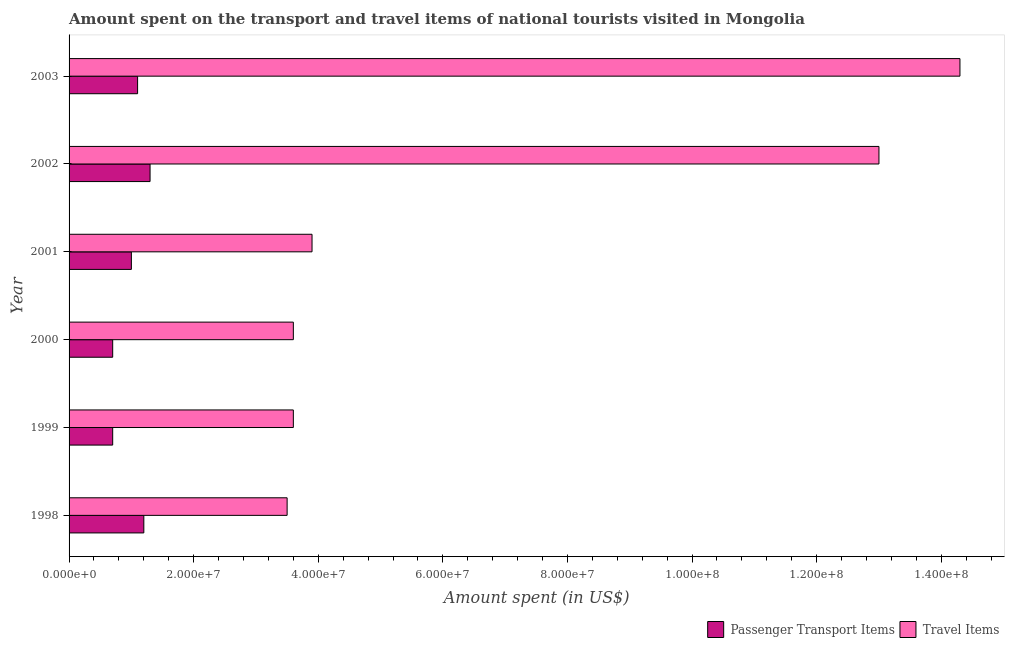How many groups of bars are there?
Keep it short and to the point. 6. Are the number of bars per tick equal to the number of legend labels?
Your answer should be very brief. Yes. How many bars are there on the 6th tick from the bottom?
Offer a terse response. 2. What is the label of the 3rd group of bars from the top?
Keep it short and to the point. 2001. In how many cases, is the number of bars for a given year not equal to the number of legend labels?
Ensure brevity in your answer.  0. What is the amount spent on passenger transport items in 1999?
Give a very brief answer. 7.00e+06. Across all years, what is the maximum amount spent on passenger transport items?
Provide a succinct answer. 1.30e+07. Across all years, what is the minimum amount spent in travel items?
Offer a very short reply. 3.50e+07. In which year was the amount spent on passenger transport items maximum?
Provide a succinct answer. 2002. In which year was the amount spent in travel items minimum?
Your response must be concise. 1998. What is the total amount spent in travel items in the graph?
Make the answer very short. 4.19e+08. What is the difference between the amount spent on passenger transport items in 1999 and that in 2001?
Your answer should be very brief. -3.00e+06. What is the difference between the amount spent in travel items in 1998 and the amount spent on passenger transport items in 2002?
Your response must be concise. 2.20e+07. What is the average amount spent on passenger transport items per year?
Keep it short and to the point. 1.00e+07. In the year 1999, what is the difference between the amount spent in travel items and amount spent on passenger transport items?
Your answer should be compact. 2.90e+07. What is the ratio of the amount spent in travel items in 2001 to that in 2003?
Keep it short and to the point. 0.27. Is the difference between the amount spent on passenger transport items in 2000 and 2001 greater than the difference between the amount spent in travel items in 2000 and 2001?
Offer a terse response. No. What is the difference between the highest and the second highest amount spent in travel items?
Make the answer very short. 1.30e+07. What is the difference between the highest and the lowest amount spent on passenger transport items?
Provide a succinct answer. 6.00e+06. What does the 1st bar from the top in 1999 represents?
Keep it short and to the point. Travel Items. What does the 2nd bar from the bottom in 2001 represents?
Provide a succinct answer. Travel Items. How many bars are there?
Offer a terse response. 12. What is the difference between two consecutive major ticks on the X-axis?
Provide a succinct answer. 2.00e+07. Are the values on the major ticks of X-axis written in scientific E-notation?
Offer a terse response. Yes. Does the graph contain grids?
Make the answer very short. No. Where does the legend appear in the graph?
Give a very brief answer. Bottom right. How are the legend labels stacked?
Provide a succinct answer. Horizontal. What is the title of the graph?
Your answer should be compact. Amount spent on the transport and travel items of national tourists visited in Mongolia. What is the label or title of the X-axis?
Offer a terse response. Amount spent (in US$). What is the Amount spent (in US$) of Passenger Transport Items in 1998?
Offer a very short reply. 1.20e+07. What is the Amount spent (in US$) of Travel Items in 1998?
Give a very brief answer. 3.50e+07. What is the Amount spent (in US$) in Travel Items in 1999?
Give a very brief answer. 3.60e+07. What is the Amount spent (in US$) in Passenger Transport Items in 2000?
Ensure brevity in your answer.  7.00e+06. What is the Amount spent (in US$) in Travel Items in 2000?
Provide a succinct answer. 3.60e+07. What is the Amount spent (in US$) in Travel Items in 2001?
Your answer should be very brief. 3.90e+07. What is the Amount spent (in US$) of Passenger Transport Items in 2002?
Offer a very short reply. 1.30e+07. What is the Amount spent (in US$) of Travel Items in 2002?
Ensure brevity in your answer.  1.30e+08. What is the Amount spent (in US$) of Passenger Transport Items in 2003?
Provide a short and direct response. 1.10e+07. What is the Amount spent (in US$) in Travel Items in 2003?
Your response must be concise. 1.43e+08. Across all years, what is the maximum Amount spent (in US$) of Passenger Transport Items?
Offer a very short reply. 1.30e+07. Across all years, what is the maximum Amount spent (in US$) in Travel Items?
Your response must be concise. 1.43e+08. Across all years, what is the minimum Amount spent (in US$) in Passenger Transport Items?
Ensure brevity in your answer.  7.00e+06. Across all years, what is the minimum Amount spent (in US$) of Travel Items?
Ensure brevity in your answer.  3.50e+07. What is the total Amount spent (in US$) in Passenger Transport Items in the graph?
Provide a succinct answer. 6.00e+07. What is the total Amount spent (in US$) of Travel Items in the graph?
Offer a terse response. 4.19e+08. What is the difference between the Amount spent (in US$) of Passenger Transport Items in 1998 and that in 1999?
Provide a succinct answer. 5.00e+06. What is the difference between the Amount spent (in US$) of Passenger Transport Items in 1998 and that in 2000?
Offer a very short reply. 5.00e+06. What is the difference between the Amount spent (in US$) in Passenger Transport Items in 1998 and that in 2001?
Ensure brevity in your answer.  2.00e+06. What is the difference between the Amount spent (in US$) of Travel Items in 1998 and that in 2001?
Offer a terse response. -4.00e+06. What is the difference between the Amount spent (in US$) in Passenger Transport Items in 1998 and that in 2002?
Provide a short and direct response. -1.00e+06. What is the difference between the Amount spent (in US$) in Travel Items in 1998 and that in 2002?
Offer a terse response. -9.50e+07. What is the difference between the Amount spent (in US$) of Passenger Transport Items in 1998 and that in 2003?
Offer a terse response. 1.00e+06. What is the difference between the Amount spent (in US$) in Travel Items in 1998 and that in 2003?
Offer a very short reply. -1.08e+08. What is the difference between the Amount spent (in US$) of Travel Items in 1999 and that in 2000?
Your answer should be compact. 0. What is the difference between the Amount spent (in US$) in Passenger Transport Items in 1999 and that in 2002?
Keep it short and to the point. -6.00e+06. What is the difference between the Amount spent (in US$) in Travel Items in 1999 and that in 2002?
Give a very brief answer. -9.40e+07. What is the difference between the Amount spent (in US$) of Passenger Transport Items in 1999 and that in 2003?
Offer a very short reply. -4.00e+06. What is the difference between the Amount spent (in US$) of Travel Items in 1999 and that in 2003?
Give a very brief answer. -1.07e+08. What is the difference between the Amount spent (in US$) in Travel Items in 2000 and that in 2001?
Your response must be concise. -3.00e+06. What is the difference between the Amount spent (in US$) in Passenger Transport Items in 2000 and that in 2002?
Your answer should be very brief. -6.00e+06. What is the difference between the Amount spent (in US$) in Travel Items in 2000 and that in 2002?
Keep it short and to the point. -9.40e+07. What is the difference between the Amount spent (in US$) in Travel Items in 2000 and that in 2003?
Offer a terse response. -1.07e+08. What is the difference between the Amount spent (in US$) of Travel Items in 2001 and that in 2002?
Provide a succinct answer. -9.10e+07. What is the difference between the Amount spent (in US$) of Passenger Transport Items in 2001 and that in 2003?
Ensure brevity in your answer.  -1.00e+06. What is the difference between the Amount spent (in US$) in Travel Items in 2001 and that in 2003?
Offer a very short reply. -1.04e+08. What is the difference between the Amount spent (in US$) of Travel Items in 2002 and that in 2003?
Provide a short and direct response. -1.30e+07. What is the difference between the Amount spent (in US$) in Passenger Transport Items in 1998 and the Amount spent (in US$) in Travel Items in 1999?
Offer a terse response. -2.40e+07. What is the difference between the Amount spent (in US$) of Passenger Transport Items in 1998 and the Amount spent (in US$) of Travel Items in 2000?
Make the answer very short. -2.40e+07. What is the difference between the Amount spent (in US$) in Passenger Transport Items in 1998 and the Amount spent (in US$) in Travel Items in 2001?
Your answer should be very brief. -2.70e+07. What is the difference between the Amount spent (in US$) of Passenger Transport Items in 1998 and the Amount spent (in US$) of Travel Items in 2002?
Provide a short and direct response. -1.18e+08. What is the difference between the Amount spent (in US$) in Passenger Transport Items in 1998 and the Amount spent (in US$) in Travel Items in 2003?
Provide a succinct answer. -1.31e+08. What is the difference between the Amount spent (in US$) in Passenger Transport Items in 1999 and the Amount spent (in US$) in Travel Items in 2000?
Provide a succinct answer. -2.90e+07. What is the difference between the Amount spent (in US$) in Passenger Transport Items in 1999 and the Amount spent (in US$) in Travel Items in 2001?
Your answer should be compact. -3.20e+07. What is the difference between the Amount spent (in US$) in Passenger Transport Items in 1999 and the Amount spent (in US$) in Travel Items in 2002?
Offer a very short reply. -1.23e+08. What is the difference between the Amount spent (in US$) in Passenger Transport Items in 1999 and the Amount spent (in US$) in Travel Items in 2003?
Make the answer very short. -1.36e+08. What is the difference between the Amount spent (in US$) of Passenger Transport Items in 2000 and the Amount spent (in US$) of Travel Items in 2001?
Provide a succinct answer. -3.20e+07. What is the difference between the Amount spent (in US$) of Passenger Transport Items in 2000 and the Amount spent (in US$) of Travel Items in 2002?
Offer a terse response. -1.23e+08. What is the difference between the Amount spent (in US$) of Passenger Transport Items in 2000 and the Amount spent (in US$) of Travel Items in 2003?
Your answer should be very brief. -1.36e+08. What is the difference between the Amount spent (in US$) in Passenger Transport Items in 2001 and the Amount spent (in US$) in Travel Items in 2002?
Your answer should be very brief. -1.20e+08. What is the difference between the Amount spent (in US$) of Passenger Transport Items in 2001 and the Amount spent (in US$) of Travel Items in 2003?
Offer a very short reply. -1.33e+08. What is the difference between the Amount spent (in US$) in Passenger Transport Items in 2002 and the Amount spent (in US$) in Travel Items in 2003?
Give a very brief answer. -1.30e+08. What is the average Amount spent (in US$) of Passenger Transport Items per year?
Offer a very short reply. 1.00e+07. What is the average Amount spent (in US$) of Travel Items per year?
Keep it short and to the point. 6.98e+07. In the year 1998, what is the difference between the Amount spent (in US$) of Passenger Transport Items and Amount spent (in US$) of Travel Items?
Make the answer very short. -2.30e+07. In the year 1999, what is the difference between the Amount spent (in US$) of Passenger Transport Items and Amount spent (in US$) of Travel Items?
Offer a very short reply. -2.90e+07. In the year 2000, what is the difference between the Amount spent (in US$) in Passenger Transport Items and Amount spent (in US$) in Travel Items?
Provide a succinct answer. -2.90e+07. In the year 2001, what is the difference between the Amount spent (in US$) of Passenger Transport Items and Amount spent (in US$) of Travel Items?
Your response must be concise. -2.90e+07. In the year 2002, what is the difference between the Amount spent (in US$) in Passenger Transport Items and Amount spent (in US$) in Travel Items?
Ensure brevity in your answer.  -1.17e+08. In the year 2003, what is the difference between the Amount spent (in US$) of Passenger Transport Items and Amount spent (in US$) of Travel Items?
Make the answer very short. -1.32e+08. What is the ratio of the Amount spent (in US$) of Passenger Transport Items in 1998 to that in 1999?
Provide a short and direct response. 1.71. What is the ratio of the Amount spent (in US$) of Travel Items in 1998 to that in 1999?
Provide a succinct answer. 0.97. What is the ratio of the Amount spent (in US$) of Passenger Transport Items in 1998 to that in 2000?
Provide a short and direct response. 1.71. What is the ratio of the Amount spent (in US$) in Travel Items in 1998 to that in 2000?
Ensure brevity in your answer.  0.97. What is the ratio of the Amount spent (in US$) in Passenger Transport Items in 1998 to that in 2001?
Provide a succinct answer. 1.2. What is the ratio of the Amount spent (in US$) of Travel Items in 1998 to that in 2001?
Offer a very short reply. 0.9. What is the ratio of the Amount spent (in US$) in Travel Items in 1998 to that in 2002?
Provide a succinct answer. 0.27. What is the ratio of the Amount spent (in US$) in Travel Items in 1998 to that in 2003?
Your response must be concise. 0.24. What is the ratio of the Amount spent (in US$) in Passenger Transport Items in 1999 to that in 2001?
Keep it short and to the point. 0.7. What is the ratio of the Amount spent (in US$) of Travel Items in 1999 to that in 2001?
Provide a short and direct response. 0.92. What is the ratio of the Amount spent (in US$) in Passenger Transport Items in 1999 to that in 2002?
Offer a very short reply. 0.54. What is the ratio of the Amount spent (in US$) of Travel Items in 1999 to that in 2002?
Make the answer very short. 0.28. What is the ratio of the Amount spent (in US$) of Passenger Transport Items in 1999 to that in 2003?
Provide a short and direct response. 0.64. What is the ratio of the Amount spent (in US$) in Travel Items in 1999 to that in 2003?
Your response must be concise. 0.25. What is the ratio of the Amount spent (in US$) of Passenger Transport Items in 2000 to that in 2002?
Keep it short and to the point. 0.54. What is the ratio of the Amount spent (in US$) of Travel Items in 2000 to that in 2002?
Give a very brief answer. 0.28. What is the ratio of the Amount spent (in US$) of Passenger Transport Items in 2000 to that in 2003?
Your response must be concise. 0.64. What is the ratio of the Amount spent (in US$) in Travel Items in 2000 to that in 2003?
Provide a short and direct response. 0.25. What is the ratio of the Amount spent (in US$) in Passenger Transport Items in 2001 to that in 2002?
Your response must be concise. 0.77. What is the ratio of the Amount spent (in US$) in Travel Items in 2001 to that in 2002?
Your response must be concise. 0.3. What is the ratio of the Amount spent (in US$) in Travel Items in 2001 to that in 2003?
Your response must be concise. 0.27. What is the ratio of the Amount spent (in US$) in Passenger Transport Items in 2002 to that in 2003?
Your answer should be very brief. 1.18. What is the difference between the highest and the second highest Amount spent (in US$) in Travel Items?
Your response must be concise. 1.30e+07. What is the difference between the highest and the lowest Amount spent (in US$) of Travel Items?
Give a very brief answer. 1.08e+08. 